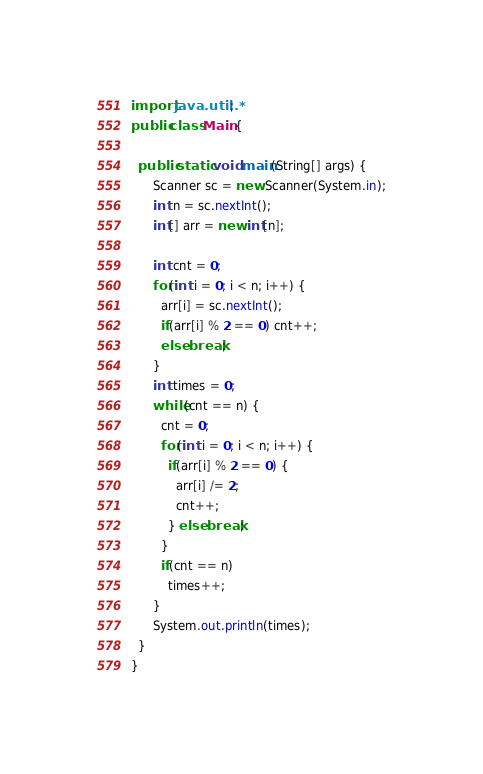<code> <loc_0><loc_0><loc_500><loc_500><_Java_>import java.util.*;
public class Main {

  public static void main(String[] args) { 
      Scanner sc = new Scanner(System.in);
      int n = sc.nextInt();
      int[] arr = new int[n];

      int cnt = 0;
      for(int i = 0; i < n; i++) {
        arr[i] = sc.nextInt();
        if(arr[i] % 2 == 0) cnt++;
        else break;
      }
      int times = 0;
      while(cnt == n) {
        cnt = 0;
        for(int i = 0; i < n; i++) {
          if(arr[i] % 2 == 0) { 
            arr[i] /= 2;
            cnt++;
          } else break;
        }
        if(cnt == n)
          times++;
      }
      System.out.println(times);
  }
}</code> 